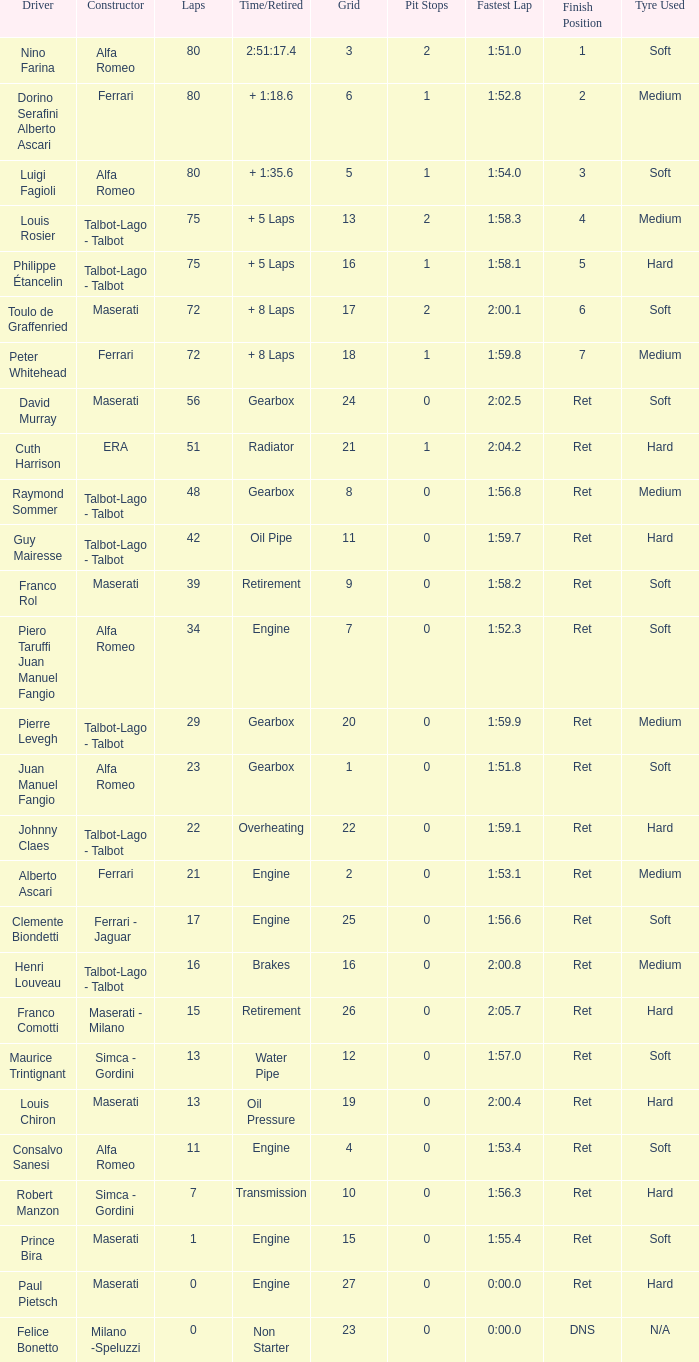When the driver is Juan Manuel Fangio and laps is less than 39, what is the highest grid? 1.0. 